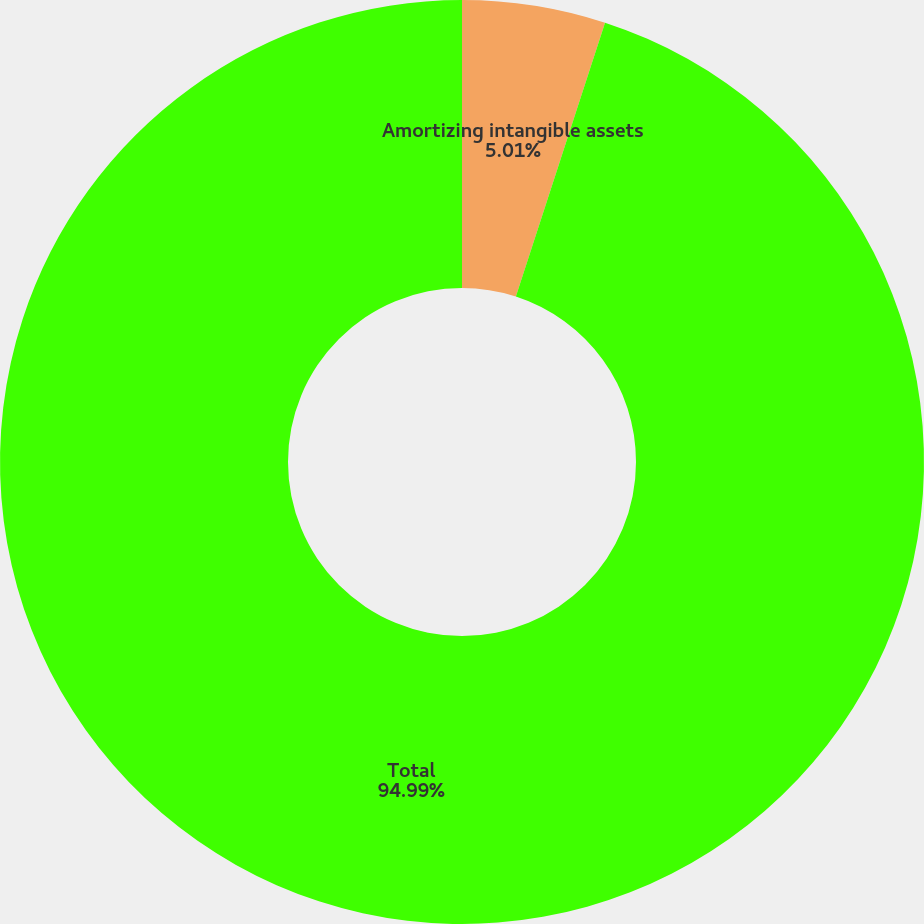Convert chart to OTSL. <chart><loc_0><loc_0><loc_500><loc_500><pie_chart><fcel>Amortizing intangible assets<fcel>Total<nl><fcel>5.01%<fcel>94.99%<nl></chart> 